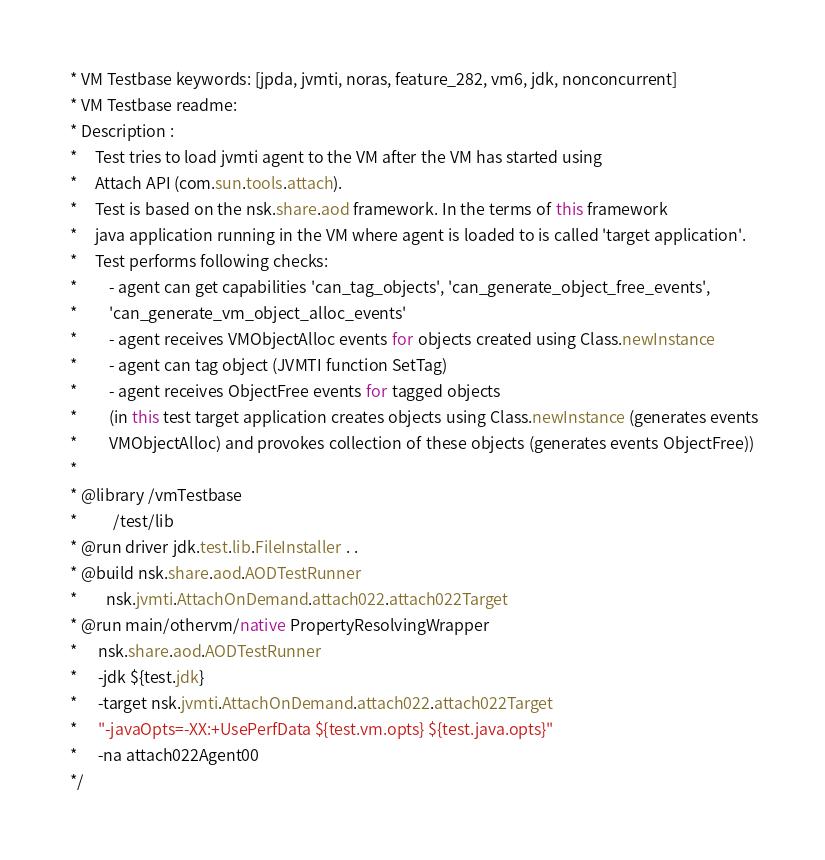Convert code to text. <code><loc_0><loc_0><loc_500><loc_500><_Java_> * VM Testbase keywords: [jpda, jvmti, noras, feature_282, vm6, jdk, nonconcurrent]
 * VM Testbase readme:
 * Description :
 *     Test tries to load jvmti agent to the VM after the VM has started using
 *     Attach API (com.sun.tools.attach).
 *     Test is based on the nsk.share.aod framework. In the terms of this framework
 *     java application running in the VM where agent is loaded to is called 'target application'.
 *     Test performs following checks:
 *         - agent can get capabilities 'can_tag_objects', 'can_generate_object_free_events',
 *         'can_generate_vm_object_alloc_events'
 *         - agent receives VMObjectAlloc events for objects created using Class.newInstance
 *         - agent can tag object (JVMTI function SetTag)
 *         - agent receives ObjectFree events for tagged objects
 *         (in this test target application creates objects using Class.newInstance (generates events
 *         VMObjectAlloc) and provokes collection of these objects (generates events ObjectFree))
 *
 * @library /vmTestbase
 *          /test/lib
 * @run driver jdk.test.lib.FileInstaller . .
 * @build nsk.share.aod.AODTestRunner
 *        nsk.jvmti.AttachOnDemand.attach022.attach022Target
 * @run main/othervm/native PropertyResolvingWrapper
 *      nsk.share.aod.AODTestRunner
 *      -jdk ${test.jdk}
 *      -target nsk.jvmti.AttachOnDemand.attach022.attach022Target
 *      "-javaOpts=-XX:+UsePerfData ${test.vm.opts} ${test.java.opts}"
 *      -na attach022Agent00
 */

</code> 